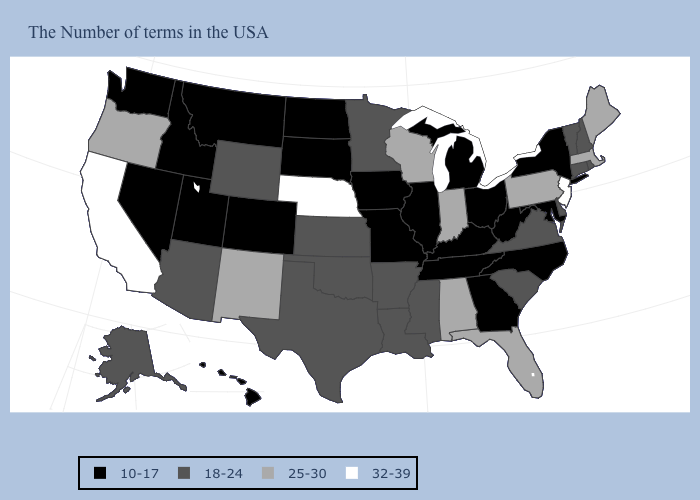What is the value of South Dakota?
Be succinct. 10-17. Which states hav the highest value in the MidWest?
Be succinct. Nebraska. Among the states that border Virginia , which have the highest value?
Concise answer only. Maryland, North Carolina, West Virginia, Kentucky, Tennessee. Name the states that have a value in the range 18-24?
Concise answer only. Rhode Island, New Hampshire, Vermont, Connecticut, Delaware, Virginia, South Carolina, Mississippi, Louisiana, Arkansas, Minnesota, Kansas, Oklahoma, Texas, Wyoming, Arizona, Alaska. What is the lowest value in the West?
Answer briefly. 10-17. What is the highest value in states that border Illinois?
Give a very brief answer. 25-30. Name the states that have a value in the range 25-30?
Answer briefly. Maine, Massachusetts, Pennsylvania, Florida, Indiana, Alabama, Wisconsin, New Mexico, Oregon. What is the value of California?
Be succinct. 32-39. What is the value of Wisconsin?
Concise answer only. 25-30. What is the lowest value in states that border West Virginia?
Answer briefly. 10-17. What is the lowest value in the USA?
Give a very brief answer. 10-17. Which states have the lowest value in the MidWest?
Short answer required. Ohio, Michigan, Illinois, Missouri, Iowa, South Dakota, North Dakota. Among the states that border Washington , does Oregon have the lowest value?
Answer briefly. No. What is the value of Vermont?
Short answer required. 18-24. How many symbols are there in the legend?
Concise answer only. 4. 